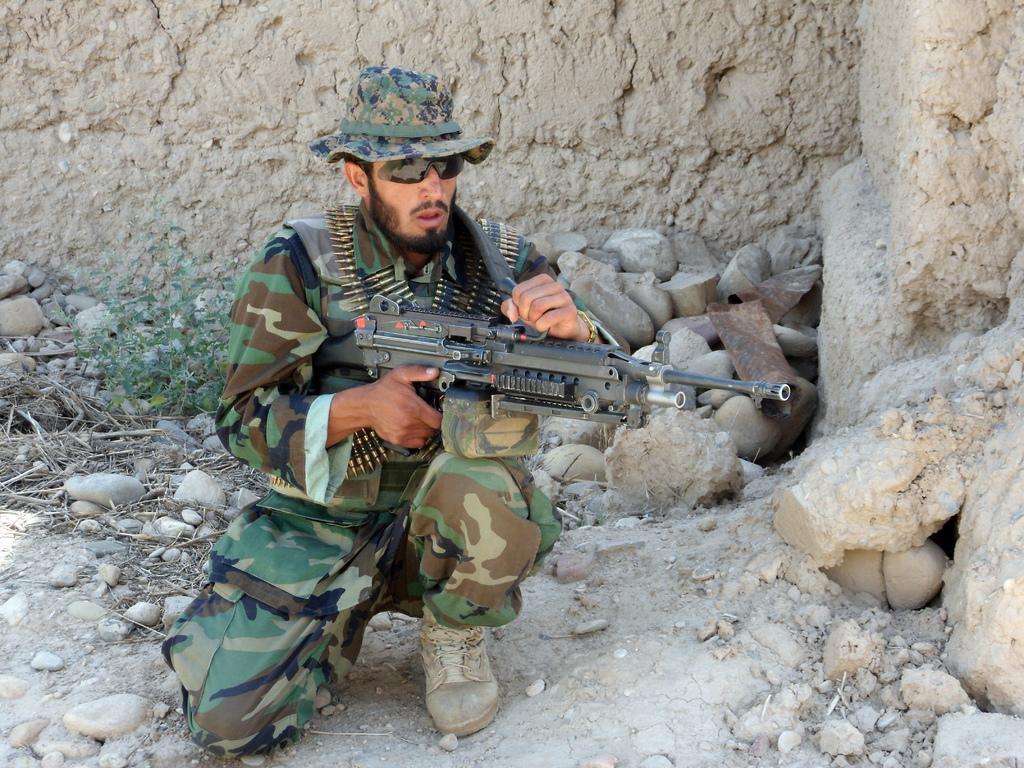Describe this image in one or two sentences. In this image we can see a person holding a gun, there are some stones, wood and a plant, in the background we can see the wall. 